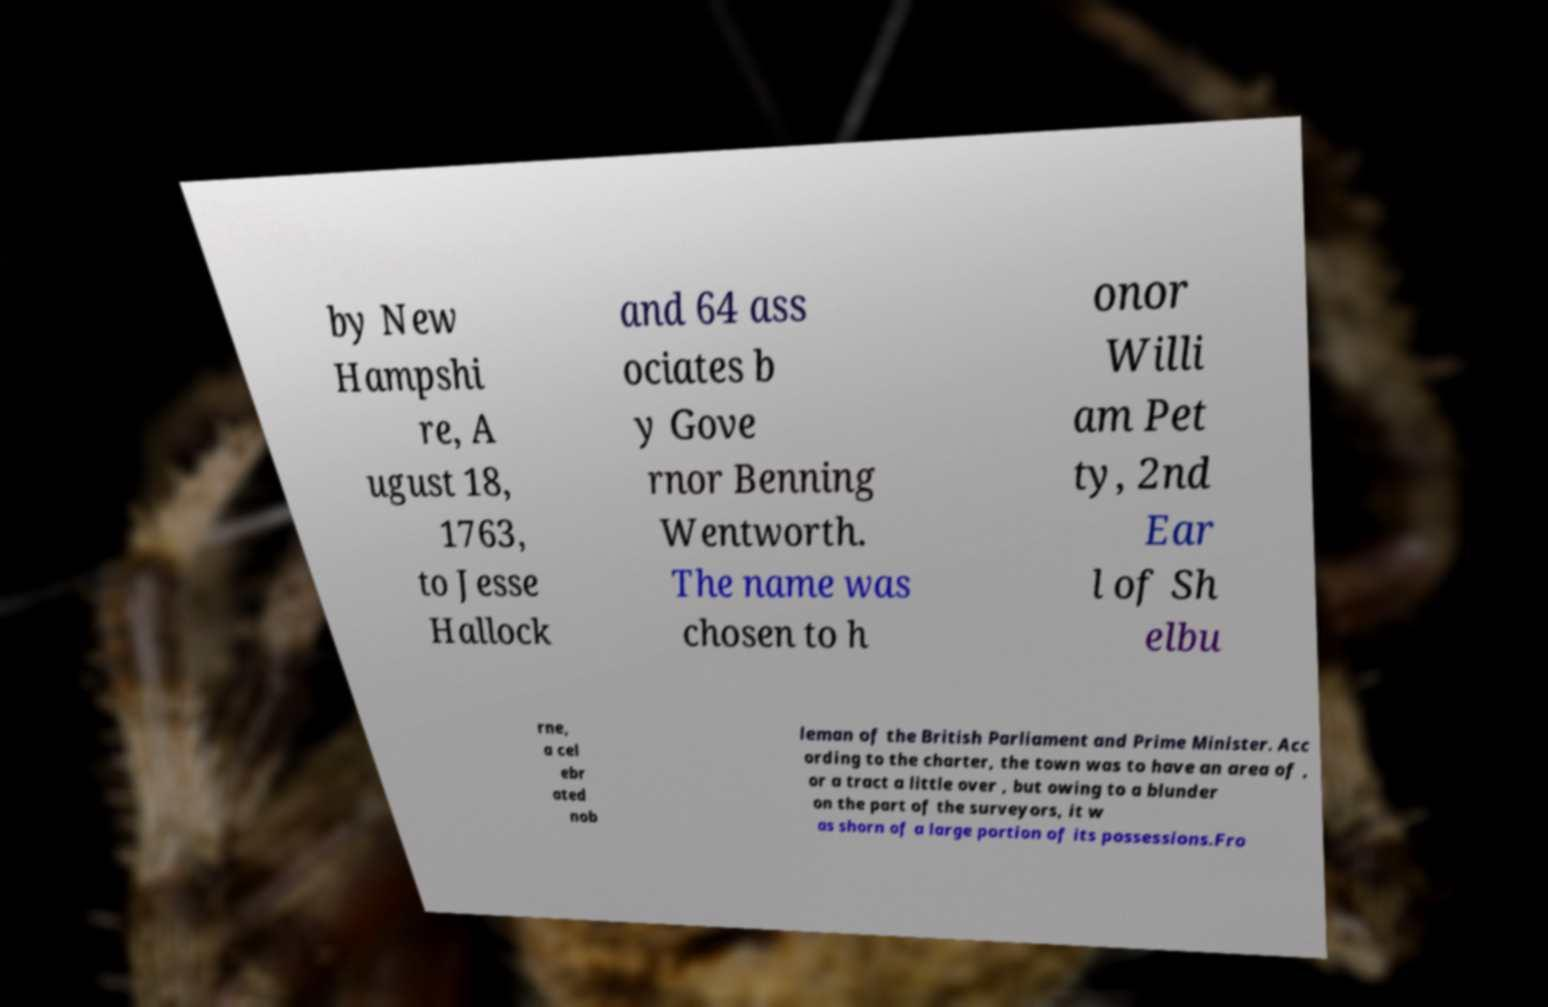I need the written content from this picture converted into text. Can you do that? by New Hampshi re, A ugust 18, 1763, to Jesse Hallock and 64 ass ociates b y Gove rnor Benning Wentworth. The name was chosen to h onor Willi am Pet ty, 2nd Ear l of Sh elbu rne, a cel ebr ated nob leman of the British Parliament and Prime Minister. Acc ording to the charter, the town was to have an area of , or a tract a little over , but owing to a blunder on the part of the surveyors, it w as shorn of a large portion of its possessions.Fro 